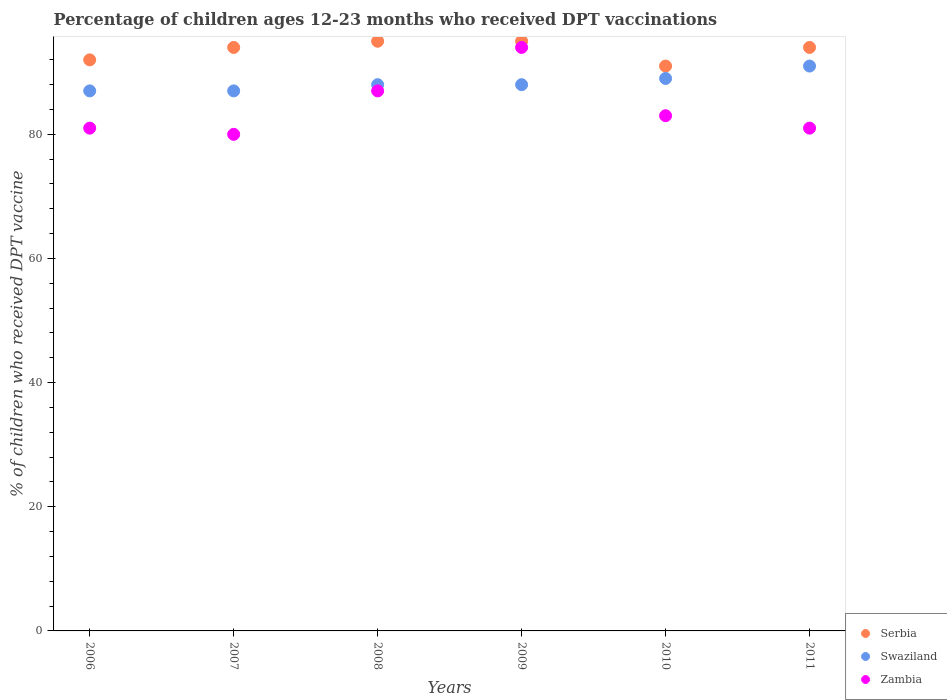How many different coloured dotlines are there?
Keep it short and to the point. 3. What is the percentage of children who received DPT vaccination in Swaziland in 2010?
Your answer should be very brief. 89. Across all years, what is the maximum percentage of children who received DPT vaccination in Zambia?
Offer a very short reply. 94. Across all years, what is the minimum percentage of children who received DPT vaccination in Zambia?
Keep it short and to the point. 80. What is the total percentage of children who received DPT vaccination in Swaziland in the graph?
Ensure brevity in your answer.  530. What is the difference between the percentage of children who received DPT vaccination in Swaziland in 2008 and the percentage of children who received DPT vaccination in Zambia in 2007?
Offer a very short reply. 8. What is the average percentage of children who received DPT vaccination in Swaziland per year?
Your answer should be very brief. 88.33. In the year 2006, what is the difference between the percentage of children who received DPT vaccination in Swaziland and percentage of children who received DPT vaccination in Serbia?
Offer a very short reply. -5. What is the ratio of the percentage of children who received DPT vaccination in Zambia in 2008 to that in 2010?
Ensure brevity in your answer.  1.05. Is the percentage of children who received DPT vaccination in Swaziland in 2008 less than that in 2011?
Ensure brevity in your answer.  Yes. Is the difference between the percentage of children who received DPT vaccination in Swaziland in 2006 and 2011 greater than the difference between the percentage of children who received DPT vaccination in Serbia in 2006 and 2011?
Offer a very short reply. No. What is the difference between the highest and the lowest percentage of children who received DPT vaccination in Swaziland?
Your response must be concise. 4. In how many years, is the percentage of children who received DPT vaccination in Swaziland greater than the average percentage of children who received DPT vaccination in Swaziland taken over all years?
Your answer should be very brief. 2. Is it the case that in every year, the sum of the percentage of children who received DPT vaccination in Serbia and percentage of children who received DPT vaccination in Swaziland  is greater than the percentage of children who received DPT vaccination in Zambia?
Provide a succinct answer. Yes. Does the percentage of children who received DPT vaccination in Serbia monotonically increase over the years?
Your response must be concise. No. Is the percentage of children who received DPT vaccination in Serbia strictly greater than the percentage of children who received DPT vaccination in Zambia over the years?
Keep it short and to the point. Yes. How many dotlines are there?
Give a very brief answer. 3. How many years are there in the graph?
Offer a terse response. 6. Does the graph contain any zero values?
Offer a very short reply. No. Does the graph contain grids?
Your response must be concise. No. How many legend labels are there?
Your answer should be very brief. 3. How are the legend labels stacked?
Provide a succinct answer. Vertical. What is the title of the graph?
Make the answer very short. Percentage of children ages 12-23 months who received DPT vaccinations. Does "Greece" appear as one of the legend labels in the graph?
Keep it short and to the point. No. What is the label or title of the X-axis?
Offer a terse response. Years. What is the label or title of the Y-axis?
Offer a very short reply. % of children who received DPT vaccine. What is the % of children who received DPT vaccine in Serbia in 2006?
Offer a terse response. 92. What is the % of children who received DPT vaccine of Serbia in 2007?
Give a very brief answer. 94. What is the % of children who received DPT vaccine of Swaziland in 2007?
Make the answer very short. 87. What is the % of children who received DPT vaccine of Zambia in 2007?
Keep it short and to the point. 80. What is the % of children who received DPT vaccine in Swaziland in 2008?
Offer a very short reply. 88. What is the % of children who received DPT vaccine of Zambia in 2008?
Your answer should be very brief. 87. What is the % of children who received DPT vaccine of Serbia in 2009?
Keep it short and to the point. 95. What is the % of children who received DPT vaccine of Swaziland in 2009?
Ensure brevity in your answer.  88. What is the % of children who received DPT vaccine of Zambia in 2009?
Provide a succinct answer. 94. What is the % of children who received DPT vaccine of Serbia in 2010?
Offer a terse response. 91. What is the % of children who received DPT vaccine of Swaziland in 2010?
Make the answer very short. 89. What is the % of children who received DPT vaccine in Serbia in 2011?
Keep it short and to the point. 94. What is the % of children who received DPT vaccine of Swaziland in 2011?
Provide a succinct answer. 91. Across all years, what is the maximum % of children who received DPT vaccine of Swaziland?
Offer a terse response. 91. Across all years, what is the maximum % of children who received DPT vaccine in Zambia?
Offer a very short reply. 94. Across all years, what is the minimum % of children who received DPT vaccine in Serbia?
Keep it short and to the point. 91. Across all years, what is the minimum % of children who received DPT vaccine of Swaziland?
Offer a terse response. 87. Across all years, what is the minimum % of children who received DPT vaccine in Zambia?
Provide a succinct answer. 80. What is the total % of children who received DPT vaccine in Serbia in the graph?
Provide a short and direct response. 561. What is the total % of children who received DPT vaccine in Swaziland in the graph?
Ensure brevity in your answer.  530. What is the total % of children who received DPT vaccine in Zambia in the graph?
Give a very brief answer. 506. What is the difference between the % of children who received DPT vaccine of Serbia in 2006 and that in 2007?
Make the answer very short. -2. What is the difference between the % of children who received DPT vaccine in Swaziland in 2006 and that in 2007?
Provide a succinct answer. 0. What is the difference between the % of children who received DPT vaccine of Zambia in 2006 and that in 2007?
Provide a succinct answer. 1. What is the difference between the % of children who received DPT vaccine of Swaziland in 2006 and that in 2008?
Give a very brief answer. -1. What is the difference between the % of children who received DPT vaccine in Zambia in 2006 and that in 2008?
Ensure brevity in your answer.  -6. What is the difference between the % of children who received DPT vaccine in Zambia in 2006 and that in 2009?
Your answer should be very brief. -13. What is the difference between the % of children who received DPT vaccine of Serbia in 2006 and that in 2010?
Offer a very short reply. 1. What is the difference between the % of children who received DPT vaccine of Swaziland in 2006 and that in 2010?
Your answer should be very brief. -2. What is the difference between the % of children who received DPT vaccine of Swaziland in 2007 and that in 2008?
Your answer should be compact. -1. What is the difference between the % of children who received DPT vaccine of Serbia in 2007 and that in 2009?
Offer a very short reply. -1. What is the difference between the % of children who received DPT vaccine in Swaziland in 2007 and that in 2009?
Keep it short and to the point. -1. What is the difference between the % of children who received DPT vaccine of Zambia in 2007 and that in 2009?
Give a very brief answer. -14. What is the difference between the % of children who received DPT vaccine of Serbia in 2007 and that in 2010?
Your answer should be very brief. 3. What is the difference between the % of children who received DPT vaccine in Serbia in 2007 and that in 2011?
Offer a terse response. 0. What is the difference between the % of children who received DPT vaccine of Swaziland in 2007 and that in 2011?
Provide a succinct answer. -4. What is the difference between the % of children who received DPT vaccine of Swaziland in 2008 and that in 2009?
Your answer should be very brief. 0. What is the difference between the % of children who received DPT vaccine of Serbia in 2008 and that in 2010?
Offer a very short reply. 4. What is the difference between the % of children who received DPT vaccine of Zambia in 2008 and that in 2010?
Ensure brevity in your answer.  4. What is the difference between the % of children who received DPT vaccine in Swaziland in 2008 and that in 2011?
Your response must be concise. -3. What is the difference between the % of children who received DPT vaccine in Zambia in 2008 and that in 2011?
Your answer should be very brief. 6. What is the difference between the % of children who received DPT vaccine in Serbia in 2009 and that in 2010?
Make the answer very short. 4. What is the difference between the % of children who received DPT vaccine of Swaziland in 2009 and that in 2011?
Make the answer very short. -3. What is the difference between the % of children who received DPT vaccine in Zambia in 2009 and that in 2011?
Your answer should be compact. 13. What is the difference between the % of children who received DPT vaccine of Zambia in 2010 and that in 2011?
Your answer should be very brief. 2. What is the difference between the % of children who received DPT vaccine of Serbia in 2006 and the % of children who received DPT vaccine of Zambia in 2007?
Offer a terse response. 12. What is the difference between the % of children who received DPT vaccine of Swaziland in 2006 and the % of children who received DPT vaccine of Zambia in 2007?
Your answer should be very brief. 7. What is the difference between the % of children who received DPT vaccine in Serbia in 2006 and the % of children who received DPT vaccine in Zambia in 2008?
Offer a terse response. 5. What is the difference between the % of children who received DPT vaccine of Swaziland in 2006 and the % of children who received DPT vaccine of Zambia in 2010?
Your answer should be very brief. 4. What is the difference between the % of children who received DPT vaccine in Serbia in 2006 and the % of children who received DPT vaccine in Swaziland in 2011?
Your response must be concise. 1. What is the difference between the % of children who received DPT vaccine in Swaziland in 2006 and the % of children who received DPT vaccine in Zambia in 2011?
Your response must be concise. 6. What is the difference between the % of children who received DPT vaccine of Serbia in 2007 and the % of children who received DPT vaccine of Swaziland in 2008?
Your answer should be compact. 6. What is the difference between the % of children who received DPT vaccine in Serbia in 2007 and the % of children who received DPT vaccine in Zambia in 2008?
Provide a succinct answer. 7. What is the difference between the % of children who received DPT vaccine in Serbia in 2007 and the % of children who received DPT vaccine in Zambia in 2009?
Offer a terse response. 0. What is the difference between the % of children who received DPT vaccine of Swaziland in 2007 and the % of children who received DPT vaccine of Zambia in 2009?
Provide a succinct answer. -7. What is the difference between the % of children who received DPT vaccine of Serbia in 2007 and the % of children who received DPT vaccine of Swaziland in 2010?
Give a very brief answer. 5. What is the difference between the % of children who received DPT vaccine in Serbia in 2007 and the % of children who received DPT vaccine in Swaziland in 2011?
Ensure brevity in your answer.  3. What is the difference between the % of children who received DPT vaccine of Swaziland in 2007 and the % of children who received DPT vaccine of Zambia in 2011?
Your answer should be very brief. 6. What is the difference between the % of children who received DPT vaccine of Serbia in 2008 and the % of children who received DPT vaccine of Swaziland in 2010?
Provide a succinct answer. 6. What is the difference between the % of children who received DPT vaccine in Swaziland in 2008 and the % of children who received DPT vaccine in Zambia in 2010?
Keep it short and to the point. 5. What is the difference between the % of children who received DPT vaccine in Serbia in 2008 and the % of children who received DPT vaccine in Swaziland in 2011?
Make the answer very short. 4. What is the difference between the % of children who received DPT vaccine of Serbia in 2009 and the % of children who received DPT vaccine of Swaziland in 2011?
Provide a short and direct response. 4. What is the difference between the % of children who received DPT vaccine in Serbia in 2009 and the % of children who received DPT vaccine in Zambia in 2011?
Your response must be concise. 14. What is the difference between the % of children who received DPT vaccine of Swaziland in 2009 and the % of children who received DPT vaccine of Zambia in 2011?
Offer a terse response. 7. What is the difference between the % of children who received DPT vaccine of Swaziland in 2010 and the % of children who received DPT vaccine of Zambia in 2011?
Provide a succinct answer. 8. What is the average % of children who received DPT vaccine of Serbia per year?
Keep it short and to the point. 93.5. What is the average % of children who received DPT vaccine in Swaziland per year?
Your answer should be compact. 88.33. What is the average % of children who received DPT vaccine of Zambia per year?
Offer a very short reply. 84.33. In the year 2006, what is the difference between the % of children who received DPT vaccine in Serbia and % of children who received DPT vaccine in Swaziland?
Give a very brief answer. 5. In the year 2006, what is the difference between the % of children who received DPT vaccine of Swaziland and % of children who received DPT vaccine of Zambia?
Provide a short and direct response. 6. In the year 2007, what is the difference between the % of children who received DPT vaccine in Serbia and % of children who received DPT vaccine in Zambia?
Provide a succinct answer. 14. In the year 2007, what is the difference between the % of children who received DPT vaccine in Swaziland and % of children who received DPT vaccine in Zambia?
Your response must be concise. 7. In the year 2008, what is the difference between the % of children who received DPT vaccine in Serbia and % of children who received DPT vaccine in Zambia?
Give a very brief answer. 8. In the year 2008, what is the difference between the % of children who received DPT vaccine in Swaziland and % of children who received DPT vaccine in Zambia?
Provide a short and direct response. 1. In the year 2009, what is the difference between the % of children who received DPT vaccine in Serbia and % of children who received DPT vaccine in Swaziland?
Ensure brevity in your answer.  7. In the year 2009, what is the difference between the % of children who received DPT vaccine in Swaziland and % of children who received DPT vaccine in Zambia?
Your response must be concise. -6. In the year 2010, what is the difference between the % of children who received DPT vaccine in Swaziland and % of children who received DPT vaccine in Zambia?
Make the answer very short. 6. In the year 2011, what is the difference between the % of children who received DPT vaccine of Serbia and % of children who received DPT vaccine of Zambia?
Ensure brevity in your answer.  13. What is the ratio of the % of children who received DPT vaccine in Serbia in 2006 to that in 2007?
Provide a succinct answer. 0.98. What is the ratio of the % of children who received DPT vaccine of Zambia in 2006 to that in 2007?
Make the answer very short. 1.01. What is the ratio of the % of children who received DPT vaccine in Serbia in 2006 to that in 2008?
Your answer should be very brief. 0.97. What is the ratio of the % of children who received DPT vaccine in Serbia in 2006 to that in 2009?
Make the answer very short. 0.97. What is the ratio of the % of children who received DPT vaccine of Zambia in 2006 to that in 2009?
Your response must be concise. 0.86. What is the ratio of the % of children who received DPT vaccine in Serbia in 2006 to that in 2010?
Offer a very short reply. 1.01. What is the ratio of the % of children who received DPT vaccine in Swaziland in 2006 to that in 2010?
Ensure brevity in your answer.  0.98. What is the ratio of the % of children who received DPT vaccine in Zambia in 2006 to that in 2010?
Your response must be concise. 0.98. What is the ratio of the % of children who received DPT vaccine of Serbia in 2006 to that in 2011?
Offer a terse response. 0.98. What is the ratio of the % of children who received DPT vaccine of Swaziland in 2006 to that in 2011?
Your response must be concise. 0.96. What is the ratio of the % of children who received DPT vaccine of Zambia in 2006 to that in 2011?
Your answer should be compact. 1. What is the ratio of the % of children who received DPT vaccine in Serbia in 2007 to that in 2008?
Your answer should be very brief. 0.99. What is the ratio of the % of children who received DPT vaccine of Swaziland in 2007 to that in 2008?
Provide a short and direct response. 0.99. What is the ratio of the % of children who received DPT vaccine of Zambia in 2007 to that in 2008?
Keep it short and to the point. 0.92. What is the ratio of the % of children who received DPT vaccine of Zambia in 2007 to that in 2009?
Offer a terse response. 0.85. What is the ratio of the % of children who received DPT vaccine in Serbia in 2007 to that in 2010?
Your response must be concise. 1.03. What is the ratio of the % of children who received DPT vaccine of Swaziland in 2007 to that in 2010?
Offer a terse response. 0.98. What is the ratio of the % of children who received DPT vaccine in Zambia in 2007 to that in 2010?
Offer a very short reply. 0.96. What is the ratio of the % of children who received DPT vaccine in Swaziland in 2007 to that in 2011?
Keep it short and to the point. 0.96. What is the ratio of the % of children who received DPT vaccine in Swaziland in 2008 to that in 2009?
Your answer should be very brief. 1. What is the ratio of the % of children who received DPT vaccine of Zambia in 2008 to that in 2009?
Provide a succinct answer. 0.93. What is the ratio of the % of children who received DPT vaccine of Serbia in 2008 to that in 2010?
Offer a very short reply. 1.04. What is the ratio of the % of children who received DPT vaccine of Swaziland in 2008 to that in 2010?
Make the answer very short. 0.99. What is the ratio of the % of children who received DPT vaccine in Zambia in 2008 to that in 2010?
Keep it short and to the point. 1.05. What is the ratio of the % of children who received DPT vaccine of Serbia in 2008 to that in 2011?
Your response must be concise. 1.01. What is the ratio of the % of children who received DPT vaccine of Swaziland in 2008 to that in 2011?
Offer a very short reply. 0.97. What is the ratio of the % of children who received DPT vaccine in Zambia in 2008 to that in 2011?
Your response must be concise. 1.07. What is the ratio of the % of children who received DPT vaccine in Serbia in 2009 to that in 2010?
Offer a very short reply. 1.04. What is the ratio of the % of children who received DPT vaccine of Zambia in 2009 to that in 2010?
Provide a short and direct response. 1.13. What is the ratio of the % of children who received DPT vaccine in Serbia in 2009 to that in 2011?
Your response must be concise. 1.01. What is the ratio of the % of children who received DPT vaccine of Swaziland in 2009 to that in 2011?
Keep it short and to the point. 0.97. What is the ratio of the % of children who received DPT vaccine of Zambia in 2009 to that in 2011?
Provide a succinct answer. 1.16. What is the ratio of the % of children who received DPT vaccine of Serbia in 2010 to that in 2011?
Ensure brevity in your answer.  0.97. What is the ratio of the % of children who received DPT vaccine in Zambia in 2010 to that in 2011?
Your response must be concise. 1.02. What is the difference between the highest and the second highest % of children who received DPT vaccine of Swaziland?
Your answer should be very brief. 2. 